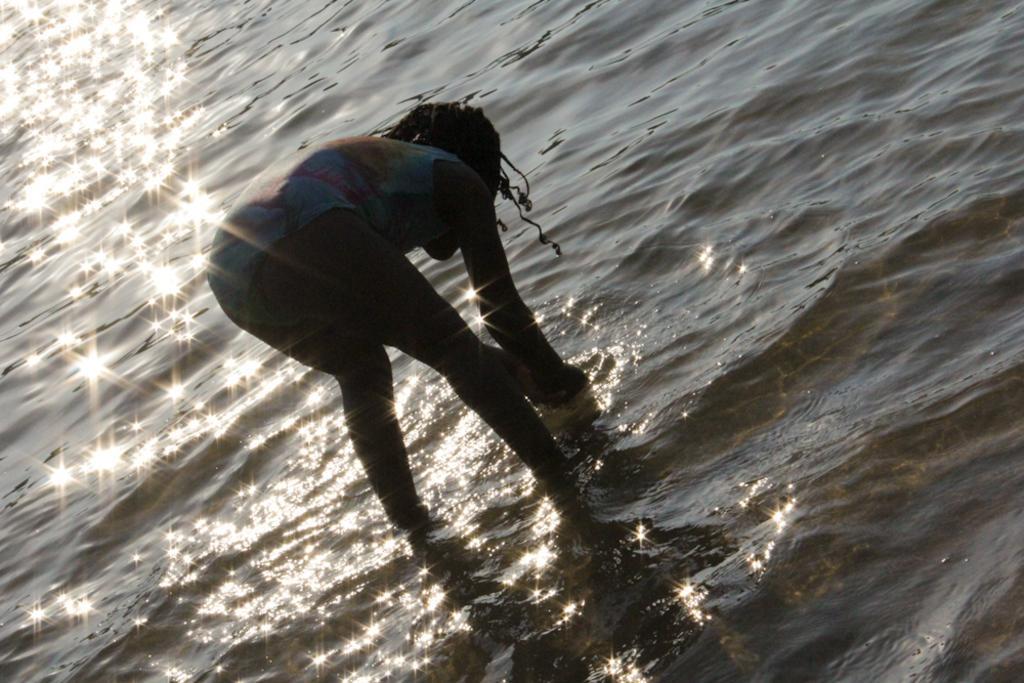Could you give a brief overview of what you see in this image? This picture is clicked outside. In the center we can see a person standing and bending forward and we can see a water body and some other objects. 